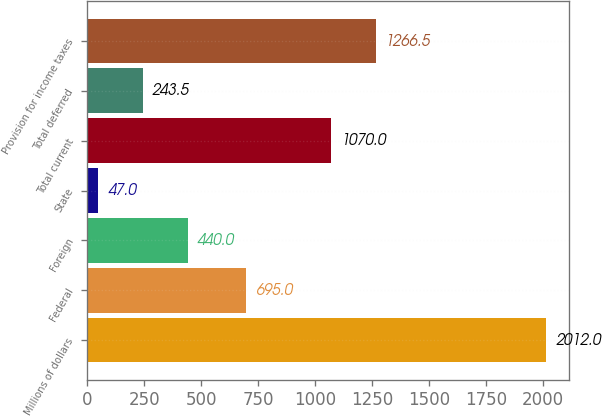<chart> <loc_0><loc_0><loc_500><loc_500><bar_chart><fcel>Millions of dollars<fcel>Federal<fcel>Foreign<fcel>State<fcel>Total current<fcel>Total deferred<fcel>Provision for income taxes<nl><fcel>2012<fcel>695<fcel>440<fcel>47<fcel>1070<fcel>243.5<fcel>1266.5<nl></chart> 